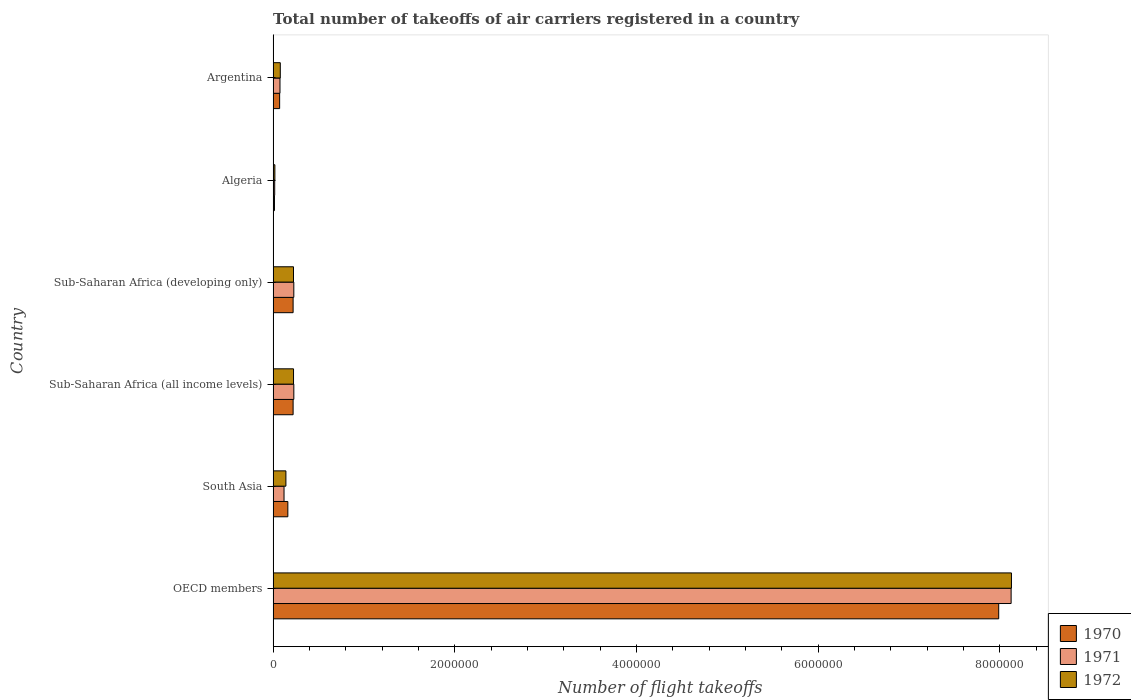How many different coloured bars are there?
Give a very brief answer. 3. How many groups of bars are there?
Provide a succinct answer. 6. Are the number of bars per tick equal to the number of legend labels?
Offer a very short reply. Yes. How many bars are there on the 4th tick from the top?
Keep it short and to the point. 3. What is the label of the 3rd group of bars from the top?
Make the answer very short. Sub-Saharan Africa (developing only). In how many cases, is the number of bars for a given country not equal to the number of legend labels?
Provide a short and direct response. 0. What is the total number of flight takeoffs in 1970 in Argentina?
Your answer should be very brief. 7.17e+04. Across all countries, what is the maximum total number of flight takeoffs in 1972?
Provide a succinct answer. 8.13e+06. Across all countries, what is the minimum total number of flight takeoffs in 1970?
Your response must be concise. 1.48e+04. In which country was the total number of flight takeoffs in 1972 minimum?
Make the answer very short. Algeria. What is the total total number of flight takeoffs in 1970 in the graph?
Your answer should be very brief. 8.68e+06. What is the difference between the total number of flight takeoffs in 1972 in Algeria and that in South Asia?
Your response must be concise. -1.22e+05. What is the difference between the total number of flight takeoffs in 1972 in Algeria and the total number of flight takeoffs in 1971 in Sub-Saharan Africa (all income levels)?
Give a very brief answer. -2.09e+05. What is the average total number of flight takeoffs in 1970 per country?
Give a very brief answer. 1.45e+06. What is the difference between the total number of flight takeoffs in 1972 and total number of flight takeoffs in 1970 in South Asia?
Give a very brief answer. -2.12e+04. In how many countries, is the total number of flight takeoffs in 1972 greater than 800000 ?
Provide a short and direct response. 1. What is the ratio of the total number of flight takeoffs in 1971 in OECD members to that in Sub-Saharan Africa (developing only)?
Give a very brief answer. 35.68. Is the total number of flight takeoffs in 1970 in Argentina less than that in OECD members?
Offer a terse response. Yes. Is the difference between the total number of flight takeoffs in 1972 in OECD members and Sub-Saharan Africa (all income levels) greater than the difference between the total number of flight takeoffs in 1970 in OECD members and Sub-Saharan Africa (all income levels)?
Offer a very short reply. Yes. What is the difference between the highest and the second highest total number of flight takeoffs in 1972?
Offer a very short reply. 7.90e+06. What is the difference between the highest and the lowest total number of flight takeoffs in 1970?
Make the answer very short. 7.97e+06. In how many countries, is the total number of flight takeoffs in 1971 greater than the average total number of flight takeoffs in 1971 taken over all countries?
Offer a terse response. 1. What does the 1st bar from the top in Argentina represents?
Ensure brevity in your answer.  1972. Is it the case that in every country, the sum of the total number of flight takeoffs in 1971 and total number of flight takeoffs in 1972 is greater than the total number of flight takeoffs in 1970?
Your answer should be very brief. Yes. What is the difference between two consecutive major ticks on the X-axis?
Keep it short and to the point. 2.00e+06. Does the graph contain any zero values?
Make the answer very short. No. How many legend labels are there?
Your answer should be very brief. 3. How are the legend labels stacked?
Offer a terse response. Vertical. What is the title of the graph?
Offer a very short reply. Total number of takeoffs of air carriers registered in a country. Does "2006" appear as one of the legend labels in the graph?
Give a very brief answer. No. What is the label or title of the X-axis?
Keep it short and to the point. Number of flight takeoffs. What is the Number of flight takeoffs of 1970 in OECD members?
Offer a terse response. 7.99e+06. What is the Number of flight takeoffs of 1971 in OECD members?
Your response must be concise. 8.12e+06. What is the Number of flight takeoffs of 1972 in OECD members?
Offer a very short reply. 8.13e+06. What is the Number of flight takeoffs of 1970 in South Asia?
Your answer should be compact. 1.62e+05. What is the Number of flight takeoffs of 1971 in South Asia?
Your answer should be very brief. 1.20e+05. What is the Number of flight takeoffs of 1972 in South Asia?
Make the answer very short. 1.41e+05. What is the Number of flight takeoffs in 1970 in Sub-Saharan Africa (all income levels)?
Your answer should be compact. 2.20e+05. What is the Number of flight takeoffs of 1971 in Sub-Saharan Africa (all income levels)?
Offer a very short reply. 2.28e+05. What is the Number of flight takeoffs in 1972 in Sub-Saharan Africa (all income levels)?
Your answer should be compact. 2.25e+05. What is the Number of flight takeoffs in 1971 in Sub-Saharan Africa (developing only)?
Your answer should be very brief. 2.28e+05. What is the Number of flight takeoffs of 1972 in Sub-Saharan Africa (developing only)?
Provide a succinct answer. 2.24e+05. What is the Number of flight takeoffs of 1970 in Algeria?
Keep it short and to the point. 1.48e+04. What is the Number of flight takeoffs of 1971 in Algeria?
Offer a very short reply. 1.74e+04. What is the Number of flight takeoffs in 1972 in Algeria?
Provide a succinct answer. 1.93e+04. What is the Number of flight takeoffs in 1970 in Argentina?
Provide a succinct answer. 7.17e+04. What is the Number of flight takeoffs in 1971 in Argentina?
Your answer should be very brief. 7.56e+04. What is the Number of flight takeoffs in 1972 in Argentina?
Ensure brevity in your answer.  7.90e+04. Across all countries, what is the maximum Number of flight takeoffs of 1970?
Keep it short and to the point. 7.99e+06. Across all countries, what is the maximum Number of flight takeoffs in 1971?
Your answer should be compact. 8.12e+06. Across all countries, what is the maximum Number of flight takeoffs in 1972?
Provide a succinct answer. 8.13e+06. Across all countries, what is the minimum Number of flight takeoffs of 1970?
Your answer should be very brief. 1.48e+04. Across all countries, what is the minimum Number of flight takeoffs in 1971?
Keep it short and to the point. 1.74e+04. Across all countries, what is the minimum Number of flight takeoffs in 1972?
Offer a very short reply. 1.93e+04. What is the total Number of flight takeoffs of 1970 in the graph?
Offer a very short reply. 8.68e+06. What is the total Number of flight takeoffs of 1971 in the graph?
Offer a very short reply. 8.79e+06. What is the total Number of flight takeoffs in 1972 in the graph?
Make the answer very short. 8.82e+06. What is the difference between the Number of flight takeoffs in 1970 in OECD members and that in South Asia?
Provide a succinct answer. 7.83e+06. What is the difference between the Number of flight takeoffs of 1971 in OECD members and that in South Asia?
Ensure brevity in your answer.  8.00e+06. What is the difference between the Number of flight takeoffs of 1972 in OECD members and that in South Asia?
Your answer should be compact. 7.99e+06. What is the difference between the Number of flight takeoffs of 1970 in OECD members and that in Sub-Saharan Africa (all income levels)?
Keep it short and to the point. 7.77e+06. What is the difference between the Number of flight takeoffs in 1971 in OECD members and that in Sub-Saharan Africa (all income levels)?
Provide a short and direct response. 7.90e+06. What is the difference between the Number of flight takeoffs in 1972 in OECD members and that in Sub-Saharan Africa (all income levels)?
Your response must be concise. 7.90e+06. What is the difference between the Number of flight takeoffs in 1970 in OECD members and that in Sub-Saharan Africa (developing only)?
Give a very brief answer. 7.77e+06. What is the difference between the Number of flight takeoffs in 1971 in OECD members and that in Sub-Saharan Africa (developing only)?
Offer a very short reply. 7.90e+06. What is the difference between the Number of flight takeoffs in 1972 in OECD members and that in Sub-Saharan Africa (developing only)?
Your answer should be compact. 7.90e+06. What is the difference between the Number of flight takeoffs of 1970 in OECD members and that in Algeria?
Provide a succinct answer. 7.97e+06. What is the difference between the Number of flight takeoffs of 1971 in OECD members and that in Algeria?
Offer a terse response. 8.11e+06. What is the difference between the Number of flight takeoffs of 1972 in OECD members and that in Algeria?
Make the answer very short. 8.11e+06. What is the difference between the Number of flight takeoffs in 1970 in OECD members and that in Argentina?
Make the answer very short. 7.92e+06. What is the difference between the Number of flight takeoffs in 1971 in OECD members and that in Argentina?
Your answer should be compact. 8.05e+06. What is the difference between the Number of flight takeoffs in 1972 in OECD members and that in Argentina?
Provide a short and direct response. 8.05e+06. What is the difference between the Number of flight takeoffs in 1970 in South Asia and that in Sub-Saharan Africa (all income levels)?
Your answer should be compact. -5.80e+04. What is the difference between the Number of flight takeoffs in 1971 in South Asia and that in Sub-Saharan Africa (all income levels)?
Ensure brevity in your answer.  -1.08e+05. What is the difference between the Number of flight takeoffs of 1972 in South Asia and that in Sub-Saharan Africa (all income levels)?
Provide a short and direct response. -8.39e+04. What is the difference between the Number of flight takeoffs of 1970 in South Asia and that in Sub-Saharan Africa (developing only)?
Your answer should be very brief. -5.80e+04. What is the difference between the Number of flight takeoffs of 1971 in South Asia and that in Sub-Saharan Africa (developing only)?
Offer a terse response. -1.08e+05. What is the difference between the Number of flight takeoffs in 1972 in South Asia and that in Sub-Saharan Africa (developing only)?
Your response must be concise. -8.36e+04. What is the difference between the Number of flight takeoffs in 1970 in South Asia and that in Algeria?
Ensure brevity in your answer.  1.47e+05. What is the difference between the Number of flight takeoffs in 1971 in South Asia and that in Algeria?
Your answer should be very brief. 1.03e+05. What is the difference between the Number of flight takeoffs in 1972 in South Asia and that in Algeria?
Your answer should be very brief. 1.22e+05. What is the difference between the Number of flight takeoffs in 1970 in South Asia and that in Argentina?
Offer a terse response. 9.03e+04. What is the difference between the Number of flight takeoffs in 1971 in South Asia and that in Argentina?
Your answer should be very brief. 4.45e+04. What is the difference between the Number of flight takeoffs of 1972 in South Asia and that in Argentina?
Offer a very short reply. 6.18e+04. What is the difference between the Number of flight takeoffs of 1971 in Sub-Saharan Africa (all income levels) and that in Sub-Saharan Africa (developing only)?
Provide a succinct answer. 300. What is the difference between the Number of flight takeoffs in 1972 in Sub-Saharan Africa (all income levels) and that in Sub-Saharan Africa (developing only)?
Offer a very short reply. 300. What is the difference between the Number of flight takeoffs in 1970 in Sub-Saharan Africa (all income levels) and that in Algeria?
Your response must be concise. 2.05e+05. What is the difference between the Number of flight takeoffs in 1971 in Sub-Saharan Africa (all income levels) and that in Algeria?
Your answer should be compact. 2.11e+05. What is the difference between the Number of flight takeoffs of 1972 in Sub-Saharan Africa (all income levels) and that in Algeria?
Give a very brief answer. 2.05e+05. What is the difference between the Number of flight takeoffs in 1970 in Sub-Saharan Africa (all income levels) and that in Argentina?
Your response must be concise. 1.48e+05. What is the difference between the Number of flight takeoffs in 1971 in Sub-Saharan Africa (all income levels) and that in Argentina?
Ensure brevity in your answer.  1.52e+05. What is the difference between the Number of flight takeoffs of 1972 in Sub-Saharan Africa (all income levels) and that in Argentina?
Offer a terse response. 1.46e+05. What is the difference between the Number of flight takeoffs in 1970 in Sub-Saharan Africa (developing only) and that in Algeria?
Offer a terse response. 2.05e+05. What is the difference between the Number of flight takeoffs of 1971 in Sub-Saharan Africa (developing only) and that in Algeria?
Provide a succinct answer. 2.10e+05. What is the difference between the Number of flight takeoffs of 1972 in Sub-Saharan Africa (developing only) and that in Algeria?
Your answer should be compact. 2.05e+05. What is the difference between the Number of flight takeoffs of 1970 in Sub-Saharan Africa (developing only) and that in Argentina?
Offer a terse response. 1.48e+05. What is the difference between the Number of flight takeoffs of 1971 in Sub-Saharan Africa (developing only) and that in Argentina?
Ensure brevity in your answer.  1.52e+05. What is the difference between the Number of flight takeoffs of 1972 in Sub-Saharan Africa (developing only) and that in Argentina?
Your answer should be compact. 1.45e+05. What is the difference between the Number of flight takeoffs in 1970 in Algeria and that in Argentina?
Offer a very short reply. -5.69e+04. What is the difference between the Number of flight takeoffs of 1971 in Algeria and that in Argentina?
Keep it short and to the point. -5.82e+04. What is the difference between the Number of flight takeoffs in 1972 in Algeria and that in Argentina?
Your answer should be very brief. -5.97e+04. What is the difference between the Number of flight takeoffs of 1970 in OECD members and the Number of flight takeoffs of 1971 in South Asia?
Your answer should be compact. 7.87e+06. What is the difference between the Number of flight takeoffs of 1970 in OECD members and the Number of flight takeoffs of 1972 in South Asia?
Provide a short and direct response. 7.85e+06. What is the difference between the Number of flight takeoffs of 1971 in OECD members and the Number of flight takeoffs of 1972 in South Asia?
Provide a succinct answer. 7.98e+06. What is the difference between the Number of flight takeoffs in 1970 in OECD members and the Number of flight takeoffs in 1971 in Sub-Saharan Africa (all income levels)?
Your answer should be compact. 7.76e+06. What is the difference between the Number of flight takeoffs of 1970 in OECD members and the Number of flight takeoffs of 1972 in Sub-Saharan Africa (all income levels)?
Your answer should be compact. 7.76e+06. What is the difference between the Number of flight takeoffs in 1971 in OECD members and the Number of flight takeoffs in 1972 in Sub-Saharan Africa (all income levels)?
Keep it short and to the point. 7.90e+06. What is the difference between the Number of flight takeoffs of 1970 in OECD members and the Number of flight takeoffs of 1971 in Sub-Saharan Africa (developing only)?
Provide a short and direct response. 7.76e+06. What is the difference between the Number of flight takeoffs of 1970 in OECD members and the Number of flight takeoffs of 1972 in Sub-Saharan Africa (developing only)?
Your answer should be compact. 7.76e+06. What is the difference between the Number of flight takeoffs of 1971 in OECD members and the Number of flight takeoffs of 1972 in Sub-Saharan Africa (developing only)?
Your answer should be very brief. 7.90e+06. What is the difference between the Number of flight takeoffs in 1970 in OECD members and the Number of flight takeoffs in 1971 in Algeria?
Keep it short and to the point. 7.97e+06. What is the difference between the Number of flight takeoffs in 1970 in OECD members and the Number of flight takeoffs in 1972 in Algeria?
Make the answer very short. 7.97e+06. What is the difference between the Number of flight takeoffs of 1971 in OECD members and the Number of flight takeoffs of 1972 in Algeria?
Offer a very short reply. 8.10e+06. What is the difference between the Number of flight takeoffs in 1970 in OECD members and the Number of flight takeoffs in 1971 in Argentina?
Provide a short and direct response. 7.91e+06. What is the difference between the Number of flight takeoffs in 1970 in OECD members and the Number of flight takeoffs in 1972 in Argentina?
Your response must be concise. 7.91e+06. What is the difference between the Number of flight takeoffs of 1971 in OECD members and the Number of flight takeoffs of 1972 in Argentina?
Provide a succinct answer. 8.05e+06. What is the difference between the Number of flight takeoffs of 1970 in South Asia and the Number of flight takeoffs of 1971 in Sub-Saharan Africa (all income levels)?
Provide a short and direct response. -6.60e+04. What is the difference between the Number of flight takeoffs in 1970 in South Asia and the Number of flight takeoffs in 1972 in Sub-Saharan Africa (all income levels)?
Offer a very short reply. -6.27e+04. What is the difference between the Number of flight takeoffs in 1971 in South Asia and the Number of flight takeoffs in 1972 in Sub-Saharan Africa (all income levels)?
Your answer should be compact. -1.05e+05. What is the difference between the Number of flight takeoffs in 1970 in South Asia and the Number of flight takeoffs in 1971 in Sub-Saharan Africa (developing only)?
Your answer should be compact. -6.57e+04. What is the difference between the Number of flight takeoffs of 1970 in South Asia and the Number of flight takeoffs of 1972 in Sub-Saharan Africa (developing only)?
Offer a very short reply. -6.24e+04. What is the difference between the Number of flight takeoffs of 1971 in South Asia and the Number of flight takeoffs of 1972 in Sub-Saharan Africa (developing only)?
Ensure brevity in your answer.  -1.04e+05. What is the difference between the Number of flight takeoffs in 1970 in South Asia and the Number of flight takeoffs in 1971 in Algeria?
Your response must be concise. 1.45e+05. What is the difference between the Number of flight takeoffs of 1970 in South Asia and the Number of flight takeoffs of 1972 in Algeria?
Keep it short and to the point. 1.43e+05. What is the difference between the Number of flight takeoffs of 1971 in South Asia and the Number of flight takeoffs of 1972 in Algeria?
Make the answer very short. 1.01e+05. What is the difference between the Number of flight takeoffs in 1970 in South Asia and the Number of flight takeoffs in 1971 in Argentina?
Offer a terse response. 8.64e+04. What is the difference between the Number of flight takeoffs of 1970 in South Asia and the Number of flight takeoffs of 1972 in Argentina?
Make the answer very short. 8.30e+04. What is the difference between the Number of flight takeoffs in 1971 in South Asia and the Number of flight takeoffs in 1972 in Argentina?
Provide a short and direct response. 4.11e+04. What is the difference between the Number of flight takeoffs of 1970 in Sub-Saharan Africa (all income levels) and the Number of flight takeoffs of 1971 in Sub-Saharan Africa (developing only)?
Give a very brief answer. -7700. What is the difference between the Number of flight takeoffs of 1970 in Sub-Saharan Africa (all income levels) and the Number of flight takeoffs of 1972 in Sub-Saharan Africa (developing only)?
Your answer should be very brief. -4400. What is the difference between the Number of flight takeoffs in 1971 in Sub-Saharan Africa (all income levels) and the Number of flight takeoffs in 1972 in Sub-Saharan Africa (developing only)?
Your response must be concise. 3600. What is the difference between the Number of flight takeoffs of 1970 in Sub-Saharan Africa (all income levels) and the Number of flight takeoffs of 1971 in Algeria?
Provide a succinct answer. 2.03e+05. What is the difference between the Number of flight takeoffs in 1970 in Sub-Saharan Africa (all income levels) and the Number of flight takeoffs in 1972 in Algeria?
Make the answer very short. 2.01e+05. What is the difference between the Number of flight takeoffs of 1971 in Sub-Saharan Africa (all income levels) and the Number of flight takeoffs of 1972 in Algeria?
Ensure brevity in your answer.  2.09e+05. What is the difference between the Number of flight takeoffs in 1970 in Sub-Saharan Africa (all income levels) and the Number of flight takeoffs in 1971 in Argentina?
Give a very brief answer. 1.44e+05. What is the difference between the Number of flight takeoffs of 1970 in Sub-Saharan Africa (all income levels) and the Number of flight takeoffs of 1972 in Argentina?
Provide a short and direct response. 1.41e+05. What is the difference between the Number of flight takeoffs in 1971 in Sub-Saharan Africa (all income levels) and the Number of flight takeoffs in 1972 in Argentina?
Your response must be concise. 1.49e+05. What is the difference between the Number of flight takeoffs of 1970 in Sub-Saharan Africa (developing only) and the Number of flight takeoffs of 1971 in Algeria?
Give a very brief answer. 2.03e+05. What is the difference between the Number of flight takeoffs of 1970 in Sub-Saharan Africa (developing only) and the Number of flight takeoffs of 1972 in Algeria?
Keep it short and to the point. 2.01e+05. What is the difference between the Number of flight takeoffs in 1971 in Sub-Saharan Africa (developing only) and the Number of flight takeoffs in 1972 in Algeria?
Offer a very short reply. 2.08e+05. What is the difference between the Number of flight takeoffs in 1970 in Sub-Saharan Africa (developing only) and the Number of flight takeoffs in 1971 in Argentina?
Provide a short and direct response. 1.44e+05. What is the difference between the Number of flight takeoffs of 1970 in Sub-Saharan Africa (developing only) and the Number of flight takeoffs of 1972 in Argentina?
Give a very brief answer. 1.41e+05. What is the difference between the Number of flight takeoffs in 1971 in Sub-Saharan Africa (developing only) and the Number of flight takeoffs in 1972 in Argentina?
Give a very brief answer. 1.49e+05. What is the difference between the Number of flight takeoffs in 1970 in Algeria and the Number of flight takeoffs in 1971 in Argentina?
Ensure brevity in your answer.  -6.08e+04. What is the difference between the Number of flight takeoffs of 1970 in Algeria and the Number of flight takeoffs of 1972 in Argentina?
Offer a terse response. -6.42e+04. What is the difference between the Number of flight takeoffs of 1971 in Algeria and the Number of flight takeoffs of 1972 in Argentina?
Keep it short and to the point. -6.16e+04. What is the average Number of flight takeoffs of 1970 per country?
Your answer should be very brief. 1.45e+06. What is the average Number of flight takeoffs of 1971 per country?
Offer a terse response. 1.47e+06. What is the average Number of flight takeoffs in 1972 per country?
Your answer should be very brief. 1.47e+06. What is the difference between the Number of flight takeoffs of 1970 and Number of flight takeoffs of 1971 in OECD members?
Offer a very short reply. -1.37e+05. What is the difference between the Number of flight takeoffs of 1970 and Number of flight takeoffs of 1972 in OECD members?
Your answer should be compact. -1.40e+05. What is the difference between the Number of flight takeoffs in 1971 and Number of flight takeoffs in 1972 in OECD members?
Your answer should be very brief. -3600. What is the difference between the Number of flight takeoffs of 1970 and Number of flight takeoffs of 1971 in South Asia?
Give a very brief answer. 4.19e+04. What is the difference between the Number of flight takeoffs of 1970 and Number of flight takeoffs of 1972 in South Asia?
Make the answer very short. 2.12e+04. What is the difference between the Number of flight takeoffs in 1971 and Number of flight takeoffs in 1972 in South Asia?
Ensure brevity in your answer.  -2.07e+04. What is the difference between the Number of flight takeoffs of 1970 and Number of flight takeoffs of 1971 in Sub-Saharan Africa (all income levels)?
Provide a succinct answer. -8000. What is the difference between the Number of flight takeoffs of 1970 and Number of flight takeoffs of 1972 in Sub-Saharan Africa (all income levels)?
Keep it short and to the point. -4700. What is the difference between the Number of flight takeoffs in 1971 and Number of flight takeoffs in 1972 in Sub-Saharan Africa (all income levels)?
Make the answer very short. 3300. What is the difference between the Number of flight takeoffs in 1970 and Number of flight takeoffs in 1971 in Sub-Saharan Africa (developing only)?
Keep it short and to the point. -7700. What is the difference between the Number of flight takeoffs in 1970 and Number of flight takeoffs in 1972 in Sub-Saharan Africa (developing only)?
Ensure brevity in your answer.  -4400. What is the difference between the Number of flight takeoffs in 1971 and Number of flight takeoffs in 1972 in Sub-Saharan Africa (developing only)?
Provide a short and direct response. 3300. What is the difference between the Number of flight takeoffs of 1970 and Number of flight takeoffs of 1971 in Algeria?
Ensure brevity in your answer.  -2600. What is the difference between the Number of flight takeoffs of 1970 and Number of flight takeoffs of 1972 in Algeria?
Ensure brevity in your answer.  -4500. What is the difference between the Number of flight takeoffs in 1971 and Number of flight takeoffs in 1972 in Algeria?
Keep it short and to the point. -1900. What is the difference between the Number of flight takeoffs of 1970 and Number of flight takeoffs of 1971 in Argentina?
Provide a succinct answer. -3900. What is the difference between the Number of flight takeoffs in 1970 and Number of flight takeoffs in 1972 in Argentina?
Provide a succinct answer. -7300. What is the difference between the Number of flight takeoffs in 1971 and Number of flight takeoffs in 1972 in Argentina?
Your answer should be compact. -3400. What is the ratio of the Number of flight takeoffs of 1970 in OECD members to that in South Asia?
Make the answer very short. 49.3. What is the ratio of the Number of flight takeoffs in 1971 in OECD members to that in South Asia?
Ensure brevity in your answer.  67.64. What is the ratio of the Number of flight takeoffs of 1972 in OECD members to that in South Asia?
Offer a very short reply. 57.73. What is the ratio of the Number of flight takeoffs of 1970 in OECD members to that in Sub-Saharan Africa (all income levels)?
Offer a terse response. 36.31. What is the ratio of the Number of flight takeoffs in 1971 in OECD members to that in Sub-Saharan Africa (all income levels)?
Make the answer very short. 35.63. What is the ratio of the Number of flight takeoffs in 1972 in OECD members to that in Sub-Saharan Africa (all income levels)?
Your answer should be compact. 36.17. What is the ratio of the Number of flight takeoffs of 1970 in OECD members to that in Sub-Saharan Africa (developing only)?
Offer a very short reply. 36.31. What is the ratio of the Number of flight takeoffs of 1971 in OECD members to that in Sub-Saharan Africa (developing only)?
Your answer should be very brief. 35.68. What is the ratio of the Number of flight takeoffs of 1972 in OECD members to that in Sub-Saharan Africa (developing only)?
Offer a very short reply. 36.22. What is the ratio of the Number of flight takeoffs in 1970 in OECD members to that in Algeria?
Keep it short and to the point. 539.69. What is the ratio of the Number of flight takeoffs in 1971 in OECD members to that in Algeria?
Your answer should be compact. 466.9. What is the ratio of the Number of flight takeoffs in 1972 in OECD members to that in Algeria?
Your answer should be compact. 421.12. What is the ratio of the Number of flight takeoffs in 1970 in OECD members to that in Argentina?
Offer a very short reply. 111.4. What is the ratio of the Number of flight takeoffs of 1971 in OECD members to that in Argentina?
Your answer should be very brief. 107.46. What is the ratio of the Number of flight takeoffs in 1972 in OECD members to that in Argentina?
Offer a terse response. 102.88. What is the ratio of the Number of flight takeoffs in 1970 in South Asia to that in Sub-Saharan Africa (all income levels)?
Make the answer very short. 0.74. What is the ratio of the Number of flight takeoffs in 1971 in South Asia to that in Sub-Saharan Africa (all income levels)?
Give a very brief answer. 0.53. What is the ratio of the Number of flight takeoffs in 1972 in South Asia to that in Sub-Saharan Africa (all income levels)?
Your response must be concise. 0.63. What is the ratio of the Number of flight takeoffs in 1970 in South Asia to that in Sub-Saharan Africa (developing only)?
Offer a terse response. 0.74. What is the ratio of the Number of flight takeoffs in 1971 in South Asia to that in Sub-Saharan Africa (developing only)?
Provide a succinct answer. 0.53. What is the ratio of the Number of flight takeoffs of 1972 in South Asia to that in Sub-Saharan Africa (developing only)?
Ensure brevity in your answer.  0.63. What is the ratio of the Number of flight takeoffs of 1970 in South Asia to that in Algeria?
Your response must be concise. 10.95. What is the ratio of the Number of flight takeoffs in 1971 in South Asia to that in Algeria?
Make the answer very short. 6.9. What is the ratio of the Number of flight takeoffs of 1972 in South Asia to that in Algeria?
Offer a terse response. 7.3. What is the ratio of the Number of flight takeoffs of 1970 in South Asia to that in Argentina?
Provide a short and direct response. 2.26. What is the ratio of the Number of flight takeoffs in 1971 in South Asia to that in Argentina?
Ensure brevity in your answer.  1.59. What is the ratio of the Number of flight takeoffs in 1972 in South Asia to that in Argentina?
Your answer should be very brief. 1.78. What is the ratio of the Number of flight takeoffs in 1972 in Sub-Saharan Africa (all income levels) to that in Sub-Saharan Africa (developing only)?
Ensure brevity in your answer.  1. What is the ratio of the Number of flight takeoffs in 1970 in Sub-Saharan Africa (all income levels) to that in Algeria?
Give a very brief answer. 14.86. What is the ratio of the Number of flight takeoffs in 1971 in Sub-Saharan Africa (all income levels) to that in Algeria?
Give a very brief answer. 13.1. What is the ratio of the Number of flight takeoffs of 1972 in Sub-Saharan Africa (all income levels) to that in Algeria?
Ensure brevity in your answer.  11.64. What is the ratio of the Number of flight takeoffs of 1970 in Sub-Saharan Africa (all income levels) to that in Argentina?
Give a very brief answer. 3.07. What is the ratio of the Number of flight takeoffs of 1971 in Sub-Saharan Africa (all income levels) to that in Argentina?
Give a very brief answer. 3.02. What is the ratio of the Number of flight takeoffs of 1972 in Sub-Saharan Africa (all income levels) to that in Argentina?
Keep it short and to the point. 2.84. What is the ratio of the Number of flight takeoffs of 1970 in Sub-Saharan Africa (developing only) to that in Algeria?
Make the answer very short. 14.86. What is the ratio of the Number of flight takeoffs in 1971 in Sub-Saharan Africa (developing only) to that in Algeria?
Keep it short and to the point. 13.09. What is the ratio of the Number of flight takeoffs of 1972 in Sub-Saharan Africa (developing only) to that in Algeria?
Keep it short and to the point. 11.63. What is the ratio of the Number of flight takeoffs in 1970 in Sub-Saharan Africa (developing only) to that in Argentina?
Your answer should be compact. 3.07. What is the ratio of the Number of flight takeoffs of 1971 in Sub-Saharan Africa (developing only) to that in Argentina?
Offer a very short reply. 3.01. What is the ratio of the Number of flight takeoffs of 1972 in Sub-Saharan Africa (developing only) to that in Argentina?
Ensure brevity in your answer.  2.84. What is the ratio of the Number of flight takeoffs in 1970 in Algeria to that in Argentina?
Make the answer very short. 0.21. What is the ratio of the Number of flight takeoffs of 1971 in Algeria to that in Argentina?
Ensure brevity in your answer.  0.23. What is the ratio of the Number of flight takeoffs of 1972 in Algeria to that in Argentina?
Provide a succinct answer. 0.24. What is the difference between the highest and the second highest Number of flight takeoffs in 1970?
Give a very brief answer. 7.77e+06. What is the difference between the highest and the second highest Number of flight takeoffs of 1971?
Offer a very short reply. 7.90e+06. What is the difference between the highest and the second highest Number of flight takeoffs in 1972?
Keep it short and to the point. 7.90e+06. What is the difference between the highest and the lowest Number of flight takeoffs of 1970?
Provide a succinct answer. 7.97e+06. What is the difference between the highest and the lowest Number of flight takeoffs in 1971?
Your answer should be very brief. 8.11e+06. What is the difference between the highest and the lowest Number of flight takeoffs in 1972?
Your response must be concise. 8.11e+06. 